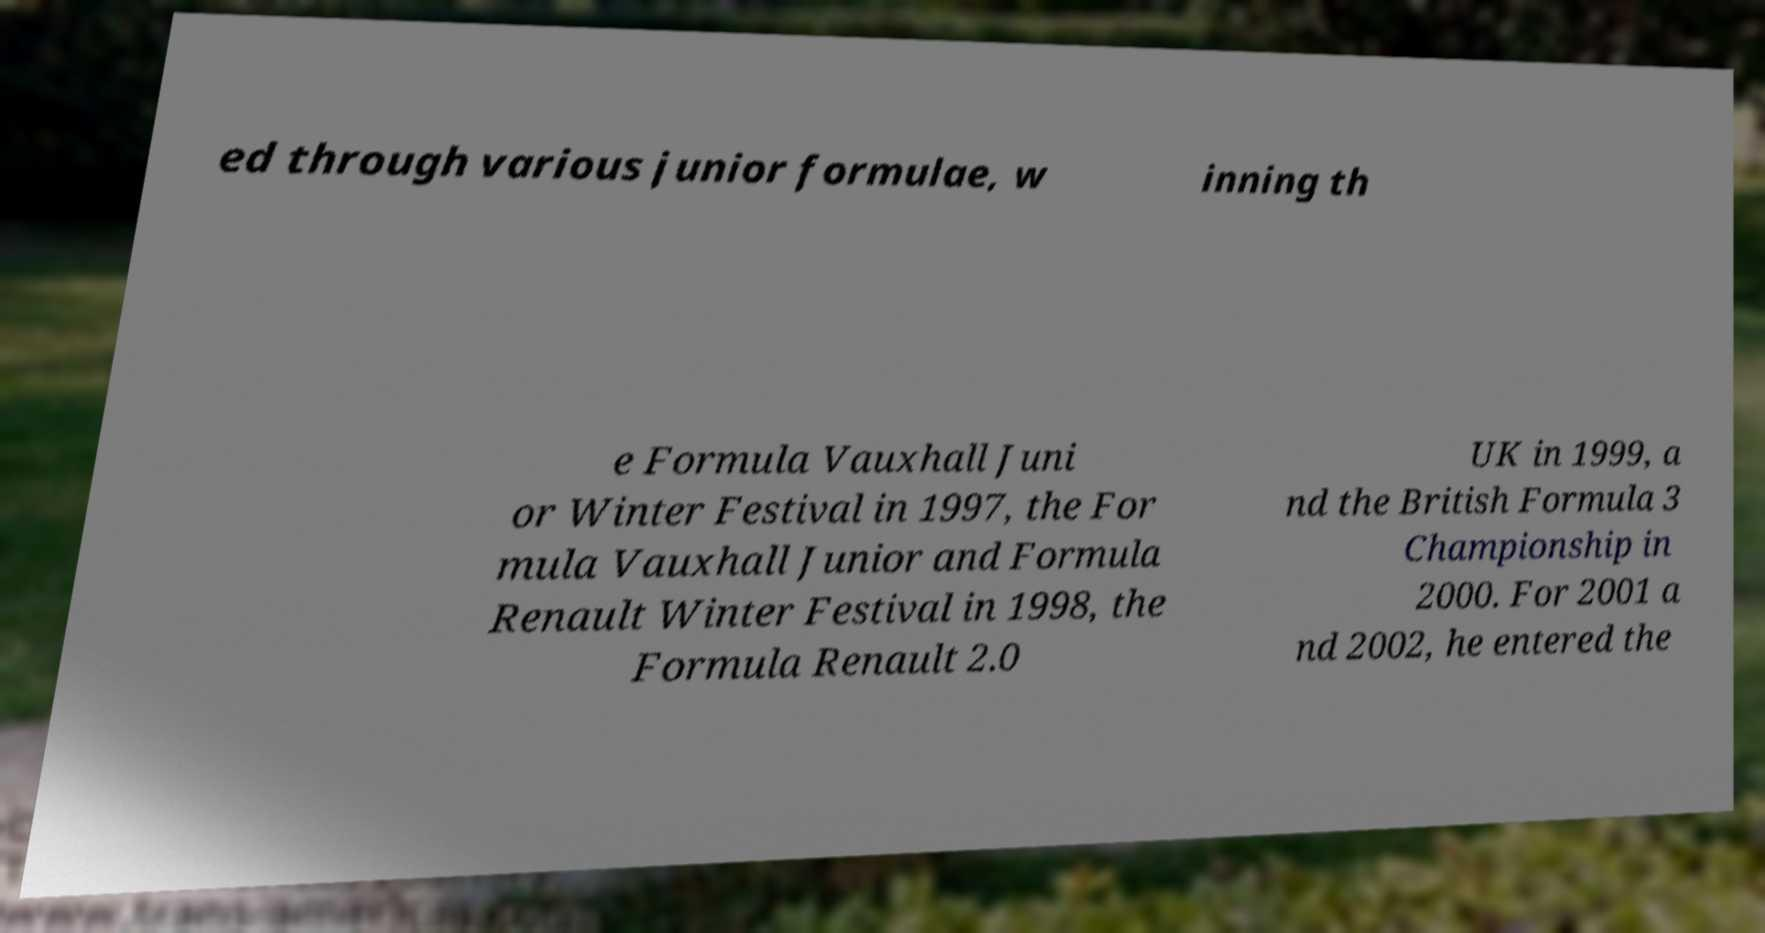There's text embedded in this image that I need extracted. Can you transcribe it verbatim? ed through various junior formulae, w inning th e Formula Vauxhall Juni or Winter Festival in 1997, the For mula Vauxhall Junior and Formula Renault Winter Festival in 1998, the Formula Renault 2.0 UK in 1999, a nd the British Formula 3 Championship in 2000. For 2001 a nd 2002, he entered the 